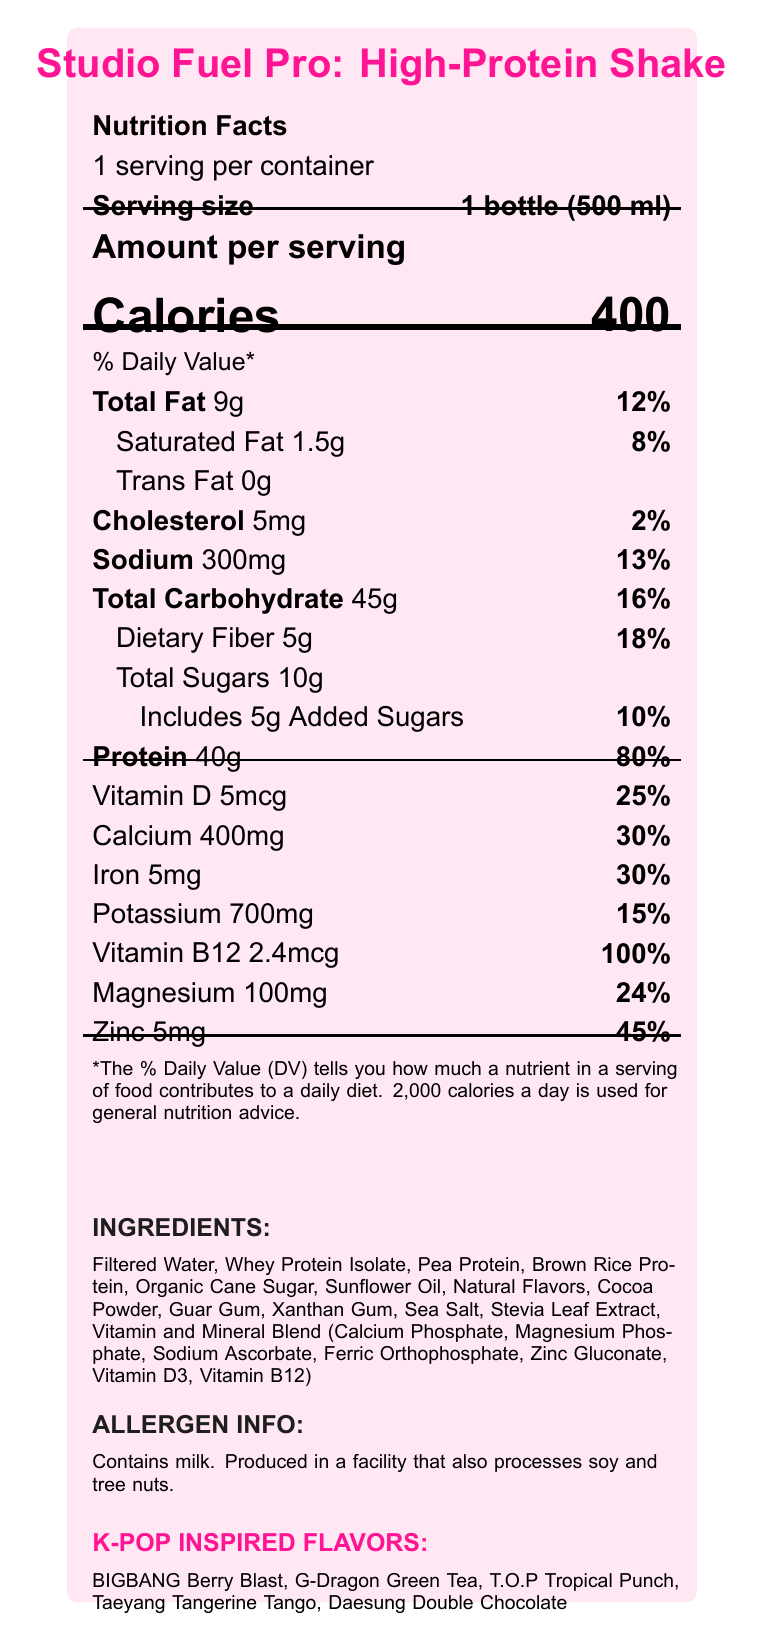what is the serving size of the Studio Fuel Pro? The serving size is clearly mentioned in the Nutrition Facts section as "1 bottle (500 ml)".
Answer: 1 bottle (500 ml) how many calories are in one serving of Studio Fuel Pro? The document lists "Calories 400" in the Amount per serving section.
Answer: 400 what percentage of the daily value for protein does one serving provide? The document lists "Protein 40g" and indicates that it provides 80% of the daily value in the % Daily Value column.
Answer: 80% what are the main ingredients in the Studio Fuel Pro shake? The ingredients are listed in the INGREDIENTS section towards the bottom of the document.
Answer: Filtered Water, Whey Protein Isolate, Pea Protein, Brown Rice Protein, Organic Cane Sugar, Sunflower Oil, Natural Flavors, Cocoa Powder, Guar Gum, Xanthan Gum, Sea Salt, Stevia Leaf Extract, Vitamin and Mineral Blend (Calcium Phosphate, Magnesium Phosphate, Sodium Ascorbate, Ferric Orthophosphate, Zinc Gluconate, Vitamin D3, Vitamin B12) what allergens are present in Studio Fuel Pro? The allergen information is explicitly provided in the ALLERGEN INFO section.
Answer: Contains milk. Produced in a facility that also processes soy and tree nuts. how much sodium is in one serving and what percentage of the daily value does it represent? The document lists "Sodium 300mg" and indicates that it provides 13% of the daily value.
Answer: 300mg, 13% How many grams of dietary fiber are in one serving? The document lists "Dietary Fiber 5g" in the Total Carbohydrate section.
Answer: 5g which of the following flavors is NOT inspired by K-POP? 
A. BIGBANG Berry Blast
B. G-Dragon Green Tea
C. BTS Banana
D. Daesung Double Chocolate The document lists the K-POP inspired flavors as BIGBANG Berry Blast, G-Dragon Green Tea, T.O.P Tropical Punch, Taeyang Tangerine Tango, and Daesung Double Chocolate. BTS Banana is not mentioned.
Answer: C. BTS Banana what percentage of the daily value for calcium does one serving provide? 
A. 15%
B. 24%
C. 25%
D. 30% The document lists "Calcium 400mg" and indicates that it provides 30% of the daily value.
Answer: D. 30% does the Studio Fuel Pro contain any trans fats? The document lists "Trans Fat 0g", indicating there are no trans fats.
Answer: No summarize the main idea of the nutrition facts label for Studio Fuel Pro. This summary captures the main points of the document, including nutritional information, purpose, flavors, and allergen warnings.
Answer: Studio Fuel Pro is a high-protein meal replacement shake with 400 calories per 500 ml bottle, designed for long studio sessions. It provides significant amounts of protein, fiber, and various vitamins and minerals, and comes in K-POP inspired flavors. It contains 9g of total fat, 5g of dietary fiber, and 40g of protein, with allergen info highlighting the presence of milk and possible contamination with soy and tree nuts. what is the main benefit of Studio Fuel Pro for musicians during studio sessions? The document lists benefits such as sustained energy for long recording sessions, mental clarity and focus, muscle recovery, and vocal health support with added B12 and zinc.
Answer: Sustained energy, mental clarity, muscle recovery, and vocal health. how much vitamin B12 is included in one serving? The document lists "Vitamin B12 2.4mcg" in the vitamin section.
Answer: 2.4mcg who manufactures Studio Fuel Pro? The document does not provide information about the manufacturer of Studio Fuel Pro.
Answer: Cannot be determined 